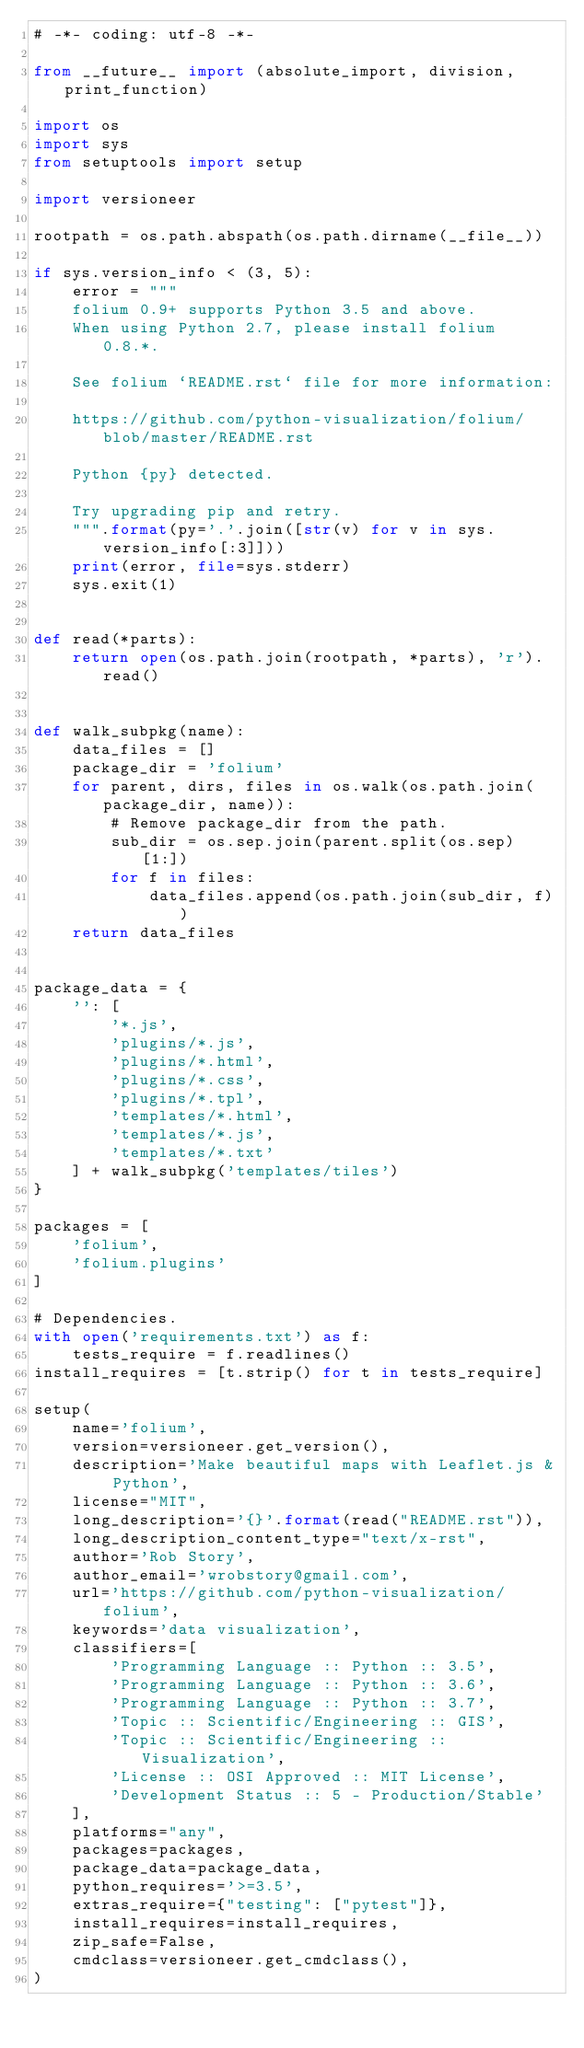<code> <loc_0><loc_0><loc_500><loc_500><_Python_># -*- coding: utf-8 -*-

from __future__ import (absolute_import, division, print_function)

import os
import sys
from setuptools import setup

import versioneer

rootpath = os.path.abspath(os.path.dirname(__file__))

if sys.version_info < (3, 5):
    error = """
    folium 0.9+ supports Python 3.5 and above.
    When using Python 2.7, please install folium 0.8.*.

    See folium `README.rst` file for more information:

    https://github.com/python-visualization/folium/blob/master/README.rst

    Python {py} detected.

    Try upgrading pip and retry.
    """.format(py='.'.join([str(v) for v in sys.version_info[:3]]))
    print(error, file=sys.stderr)
    sys.exit(1)


def read(*parts):
    return open(os.path.join(rootpath, *parts), 'r').read()


def walk_subpkg(name):
    data_files = []
    package_dir = 'folium'
    for parent, dirs, files in os.walk(os.path.join(package_dir, name)):
        # Remove package_dir from the path.
        sub_dir = os.sep.join(parent.split(os.sep)[1:])
        for f in files:
            data_files.append(os.path.join(sub_dir, f))
    return data_files


package_data = {
    '': [
        '*.js',
        'plugins/*.js',
        'plugins/*.html',
        'plugins/*.css',
        'plugins/*.tpl',
        'templates/*.html',
        'templates/*.js',
        'templates/*.txt'
    ] + walk_subpkg('templates/tiles')
}

packages = [
    'folium',
    'folium.plugins'
]

# Dependencies.
with open('requirements.txt') as f:
    tests_require = f.readlines()
install_requires = [t.strip() for t in tests_require]

setup(
    name='folium',
    version=versioneer.get_version(),
    description='Make beautiful maps with Leaflet.js & Python',
    license="MIT",
    long_description='{}'.format(read("README.rst")),
    long_description_content_type="text/x-rst",
    author='Rob Story',
    author_email='wrobstory@gmail.com',
    url='https://github.com/python-visualization/folium',
    keywords='data visualization',
    classifiers=[
        'Programming Language :: Python :: 3.5',
        'Programming Language :: Python :: 3.6',
        'Programming Language :: Python :: 3.7',
        'Topic :: Scientific/Engineering :: GIS',
        'Topic :: Scientific/Engineering :: Visualization',
        'License :: OSI Approved :: MIT License',
        'Development Status :: 5 - Production/Stable'
    ],
    platforms="any",
    packages=packages,
    package_data=package_data,
    python_requires='>=3.5',
    extras_require={"testing": ["pytest"]},
    install_requires=install_requires,
    zip_safe=False,
    cmdclass=versioneer.get_cmdclass(),
)
</code> 